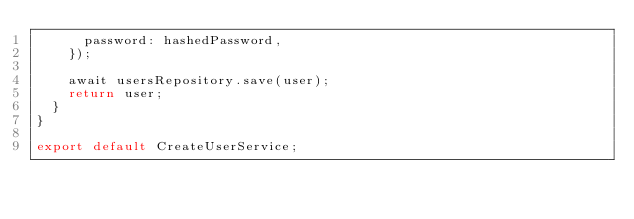<code> <loc_0><loc_0><loc_500><loc_500><_TypeScript_>      password: hashedPassword,
    });

    await usersRepository.save(user);
    return user;
  }
}

export default CreateUserService;
</code> 